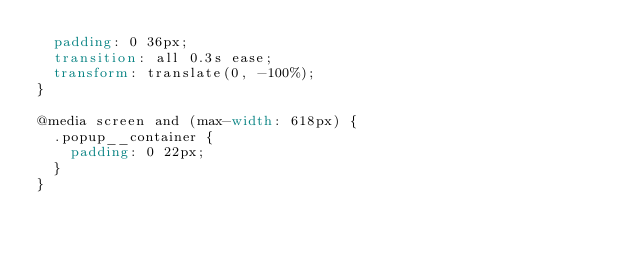<code> <loc_0><loc_0><loc_500><loc_500><_CSS_>  padding: 0 36px;
  transition: all 0.3s ease;
  transform: translate(0, -100%);
}

@media screen and (max-width: 618px) {
  .popup__container {
    padding: 0 22px;
  }
}
</code> 